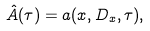<formula> <loc_0><loc_0><loc_500><loc_500>\hat { A } ( \tau ) = a ( x , D _ { x } , \tau ) ,</formula> 